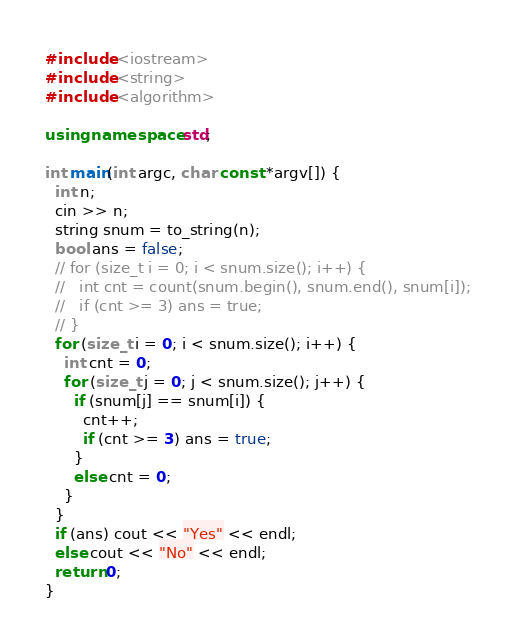Convert code to text. <code><loc_0><loc_0><loc_500><loc_500><_C++_>#include <iostream>
#include <string>
#include <algorithm>

using namespace std;

int main(int argc, char const *argv[]) {
  int n;
  cin >> n;
  string snum = to_string(n);
  bool ans = false;
  // for (size_t i = 0; i < snum.size(); i++) {
  //   int cnt = count(snum.begin(), snum.end(), snum[i]);
  //   if (cnt >= 3) ans = true;
  // }
  for (size_t i = 0; i < snum.size(); i++) {
    int cnt = 0;
    for (size_t j = 0; j < snum.size(); j++) {
      if (snum[j] == snum[i]) {
        cnt++;
        if (cnt >= 3) ans = true;
      }
      else cnt = 0;
    }
  }
  if (ans) cout << "Yes" << endl;
  else cout << "No" << endl;
  return 0;
}
</code> 